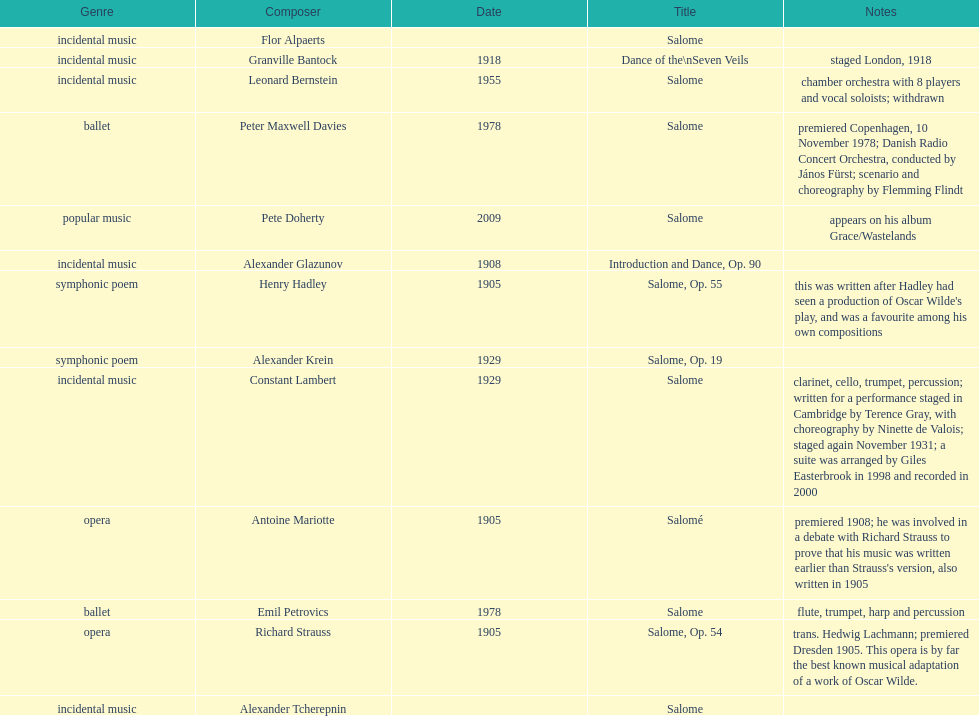Who is on top of the list? Flor Alpaerts. I'm looking to parse the entire table for insights. Could you assist me with that? {'header': ['Genre', 'Composer', 'Date', 'Title', 'Notes'], 'rows': [['incidental\xa0music', 'Flor Alpaerts', '', 'Salome', ''], ['incidental music', 'Granville Bantock', '1918', 'Dance of the\\nSeven Veils', 'staged London, 1918'], ['incidental music', 'Leonard Bernstein', '1955', 'Salome', 'chamber orchestra with 8 players and vocal soloists; withdrawn'], ['ballet', 'Peter\xa0Maxwell\xa0Davies', '1978', 'Salome', 'premiered Copenhagen, 10 November 1978; Danish Radio Concert Orchestra, conducted by János Fürst; scenario and choreography by Flemming Flindt'], ['popular music', 'Pete Doherty', '2009', 'Salome', 'appears on his album Grace/Wastelands'], ['incidental music', 'Alexander Glazunov', '1908', 'Introduction and Dance, Op. 90', ''], ['symphonic poem', 'Henry Hadley', '1905', 'Salome, Op. 55', "this was written after Hadley had seen a production of Oscar Wilde's play, and was a favourite among his own compositions"], ['symphonic poem', 'Alexander Krein', '1929', 'Salome, Op. 19', ''], ['incidental music', 'Constant Lambert', '1929', 'Salome', 'clarinet, cello, trumpet, percussion; written for a performance staged in Cambridge by Terence Gray, with choreography by Ninette de Valois; staged again November 1931; a suite was arranged by Giles Easterbrook in 1998 and recorded in 2000'], ['opera', 'Antoine Mariotte', '1905', 'Salomé', "premiered 1908; he was involved in a debate with Richard Strauss to prove that his music was written earlier than Strauss's version, also written in 1905"], ['ballet', 'Emil Petrovics', '1978', 'Salome', 'flute, trumpet, harp and percussion'], ['opera', 'Richard Strauss', '1905', 'Salome, Op. 54', 'trans. Hedwig Lachmann; premiered Dresden 1905. This opera is by far the best known musical adaptation of a work of Oscar Wilde.'], ['incidental music', 'Alexander\xa0Tcherepnin', '', 'Salome', '']]} 